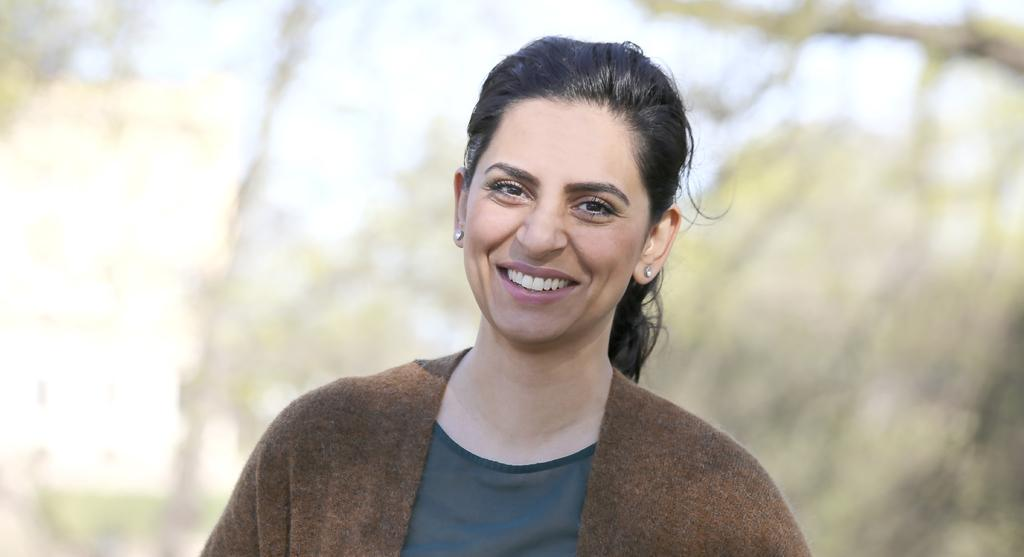Who is the main subject in the image? There is a woman in the image. What is the woman wearing? The woman is wearing a brown jacket. Can you describe the woman's hair? The woman has long hair. What can be seen in the background of the image? There is a group of trees in the background of the image. What type of goldfish can be seen swimming in the woman's hair in the image? There are no goldfish present in the image, and the woman's hair does not contain any water for a goldfish to swim in. 